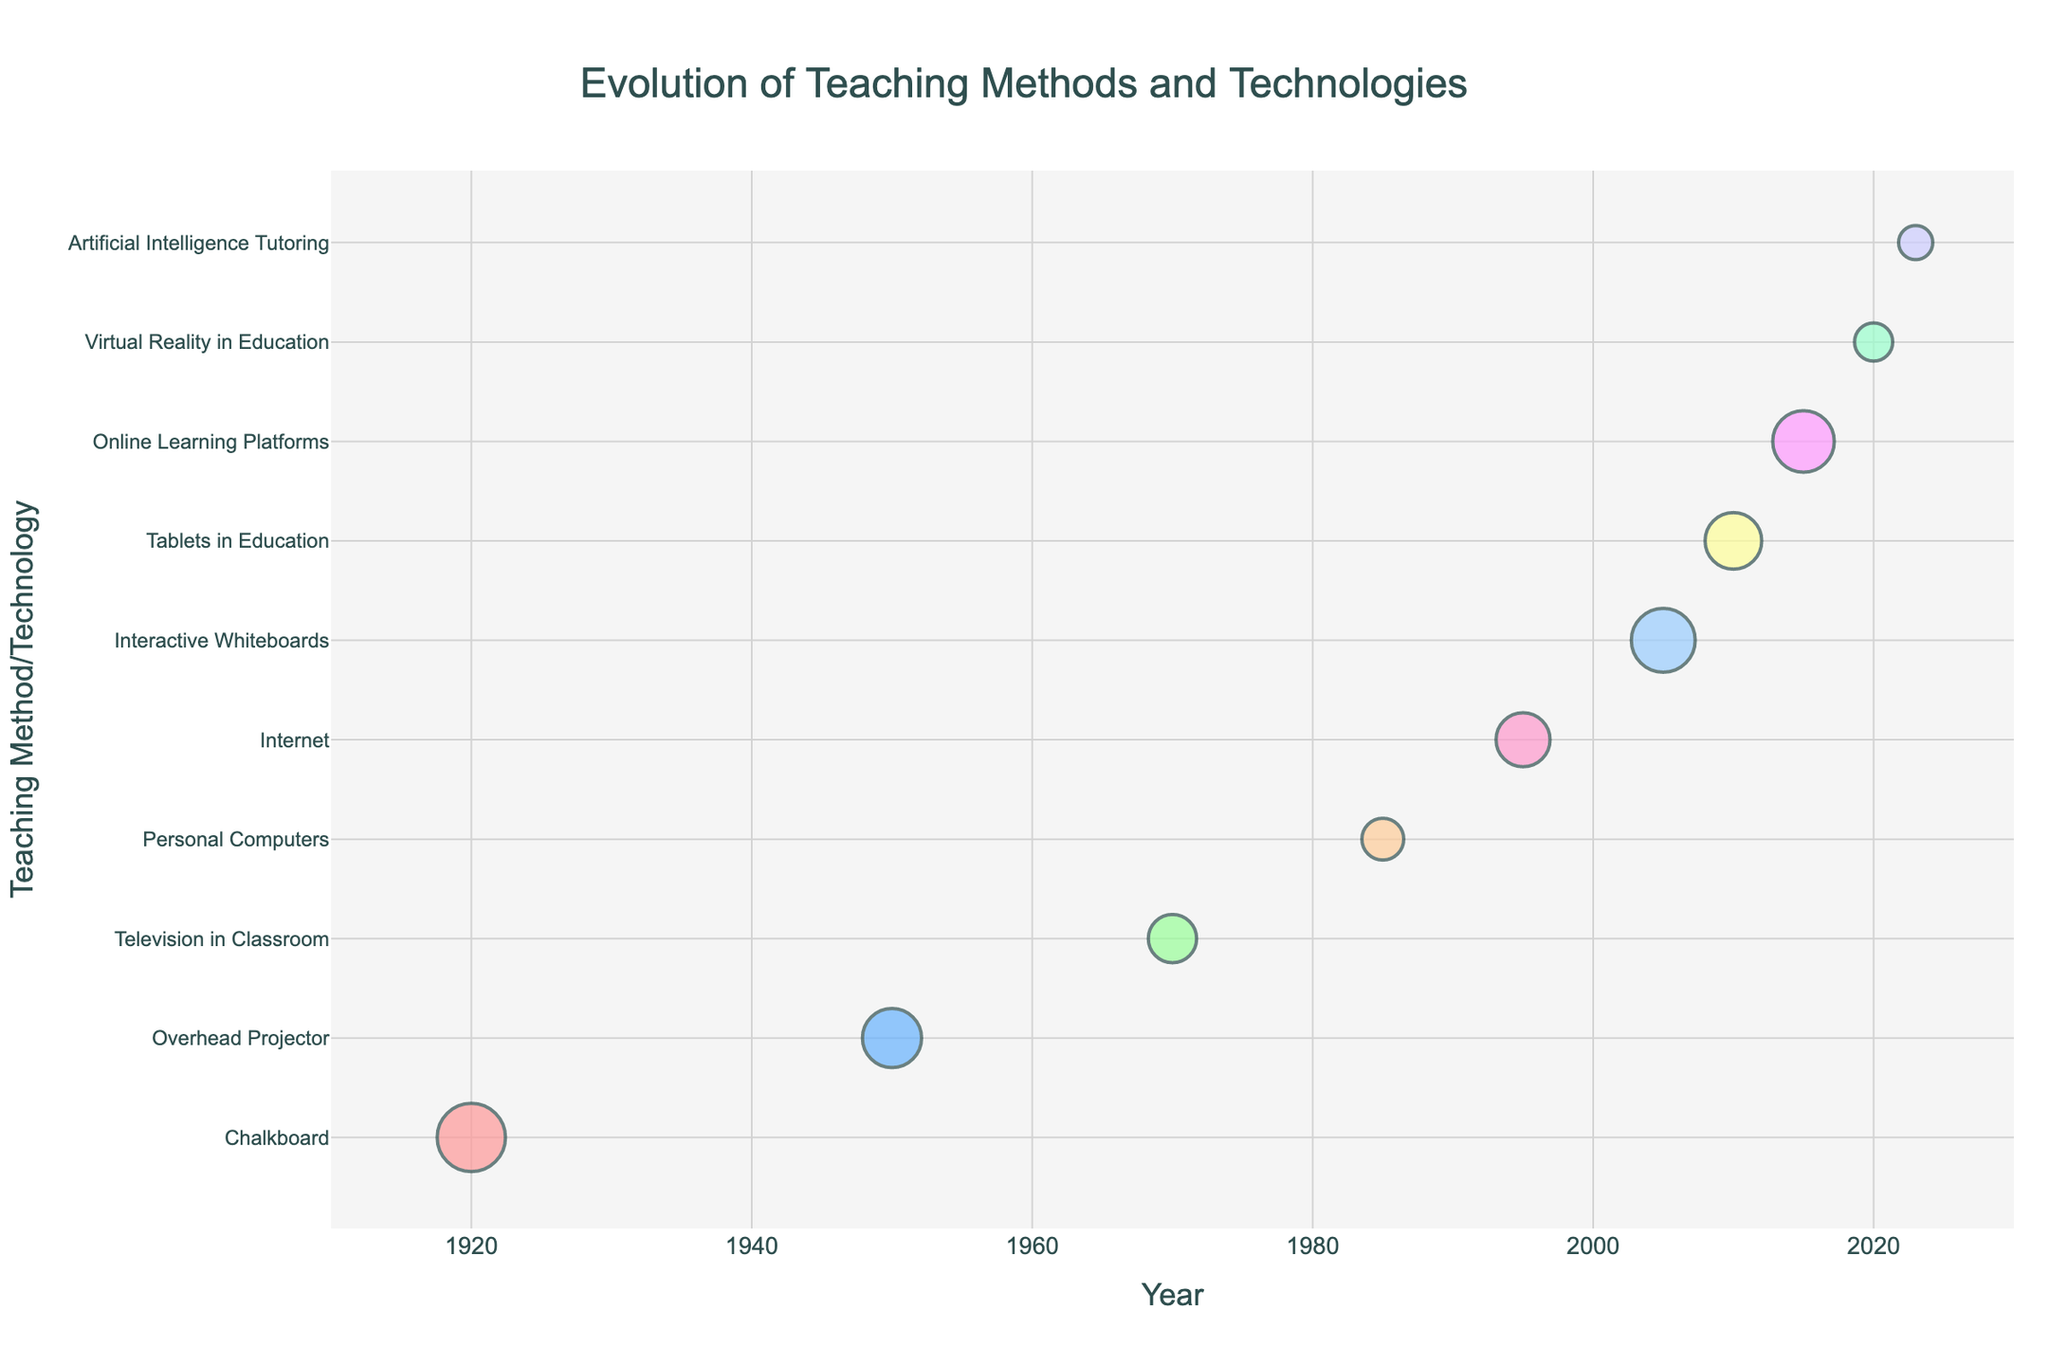What is the title of the figure? The title is usually displayed at the top of the figure and should succinctly describe the content of the figure.
Answer: "Evolution of Teaching Methods and Technologies" Which teaching method/technology had the highest adoption rate in 1920? Look for the year 1920 on the x-axis and identify the teaching method with the largest bubble size in that year.
Answer: Chalkboard How has the adoption rate of the Internet changed since its introduction in 1995? Identify the bubble size for the Internet in 1995 and note that it starts at 50%. Compare this to other technologies introduced after 1995 to see relative changes in adoption rates.
Answer: 50% Which year had the most diverse range of teaching methods/technologies adopted? Note the number of different teaching methods/technologies listed on the y-axis for each year and choose the year with the maximum count.
Answer: 2023 What is the approximate adoption rate of Tablets in Education as of 2010? Locate the bubble representing Tablets in Education for the year 2010 and estimate its size to determine the adoption rate.
Answer: 55% Compare the adoption rates of Personal Computers in 1985 and Online Learning Platforms in 2015. Which one was higher? Find the bubble sizes for Personal Computers in 1985 and Online Learning Platforms in 2015 on the y-axis and compare their sizes.
Answer: Online Learning Platforms What trend can be observed in the adoption rates of new teaching technologies over the last century? Analyze the bubble sizes for newer technologies from 1920 to 2023. Note that earlier technologies have higher adoption rates compared to more recent innovations.
Answer: Decreasing Which technology introduced in the 21st century has the highest adoption rate? Identify technologies introduced in 2000 or later and compare their bubble sizes to find the highest one.
Answer: Interactive Whiteboards How does the adoption rate of Artificial Intelligence Tutoring in 2023 compare with that of Virtual Reality in Education in 2020? Find and compare the bubble sizes of Artificial Intelligence Tutoring for 2023 and Virtual Reality in Education for 2020.
Answer: AI Tutoring is lower What are the colors used for the bubbles representing different years? Observe the color of the bubbles on the subplot that represent different years. Identify the range of colors used.
Answer: Shades of red, blue, green, orange, pink, light blue, yellow, violet, teal, light purple 